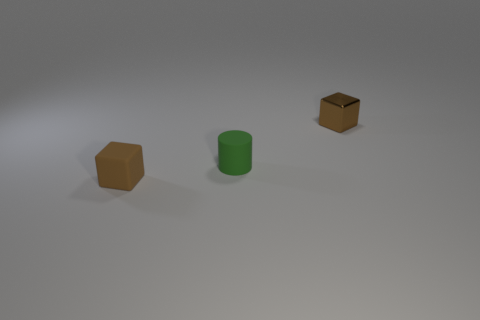Does the tiny rubber block have the same color as the shiny cube?
Offer a very short reply. Yes. There is a brown cube on the right side of the tiny brown matte block; what is it made of?
Your answer should be very brief. Metal. What number of rubber things are either big purple spheres or tiny things?
Ensure brevity in your answer.  2. Is there a blue matte thing that has the same size as the green rubber cylinder?
Provide a succinct answer. No. Are there more small brown things that are in front of the brown metallic block than cyan cylinders?
Your answer should be compact. Yes. How many small things are either brown shiny blocks or cubes?
Your response must be concise. 2. How many small brown metal objects have the same shape as the small brown matte thing?
Your response must be concise. 1. The small brown cube that is behind the tiny brown thing that is in front of the tiny brown metallic cube is made of what material?
Your answer should be compact. Metal. There is a brown block that is in front of the brown metal thing; how big is it?
Your response must be concise. Small. What number of brown things are blocks or shiny things?
Provide a short and direct response. 2. 